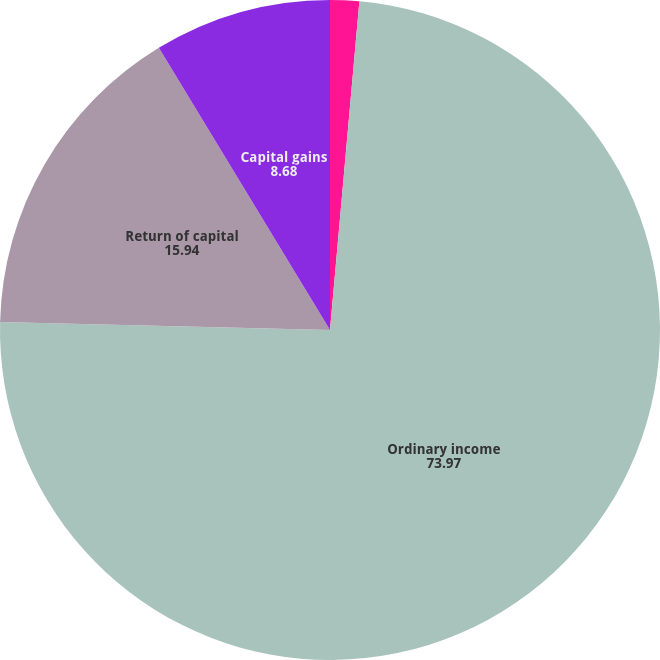Convert chart to OTSL. <chart><loc_0><loc_0><loc_500><loc_500><pie_chart><fcel>To tal dividends paid per year<fcel>Ordinary income<fcel>Return of capital<fcel>Capital gains<nl><fcel>1.42%<fcel>73.97%<fcel>15.94%<fcel>8.68%<nl></chart> 